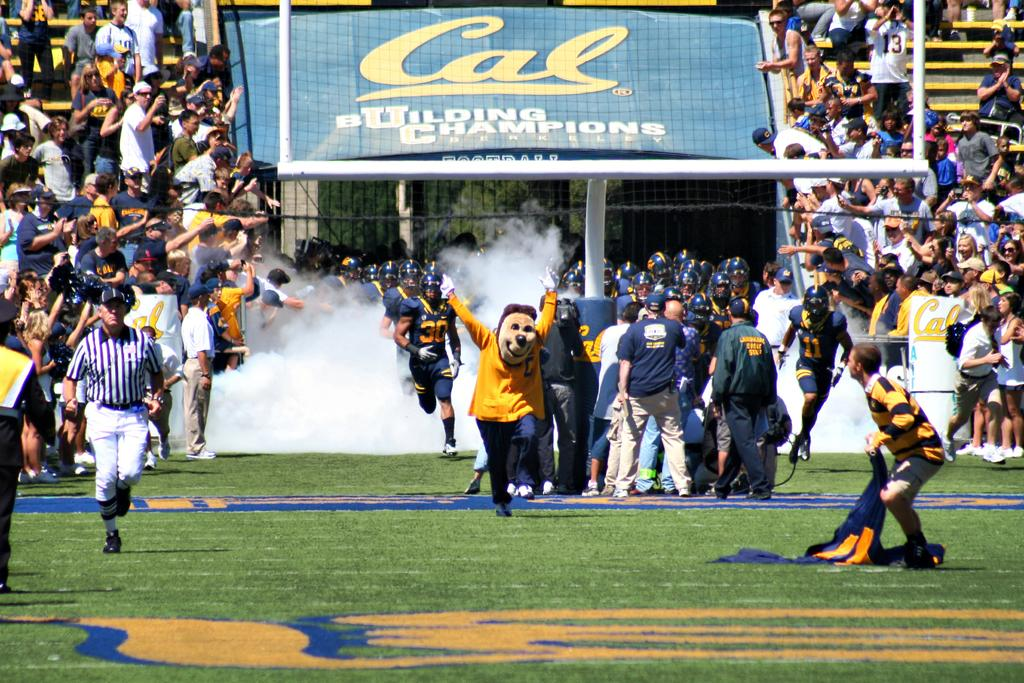<image>
Offer a succinct explanation of the picture presented. bear mascot for university of california running onto the field and a sign in the background Cal building champions 